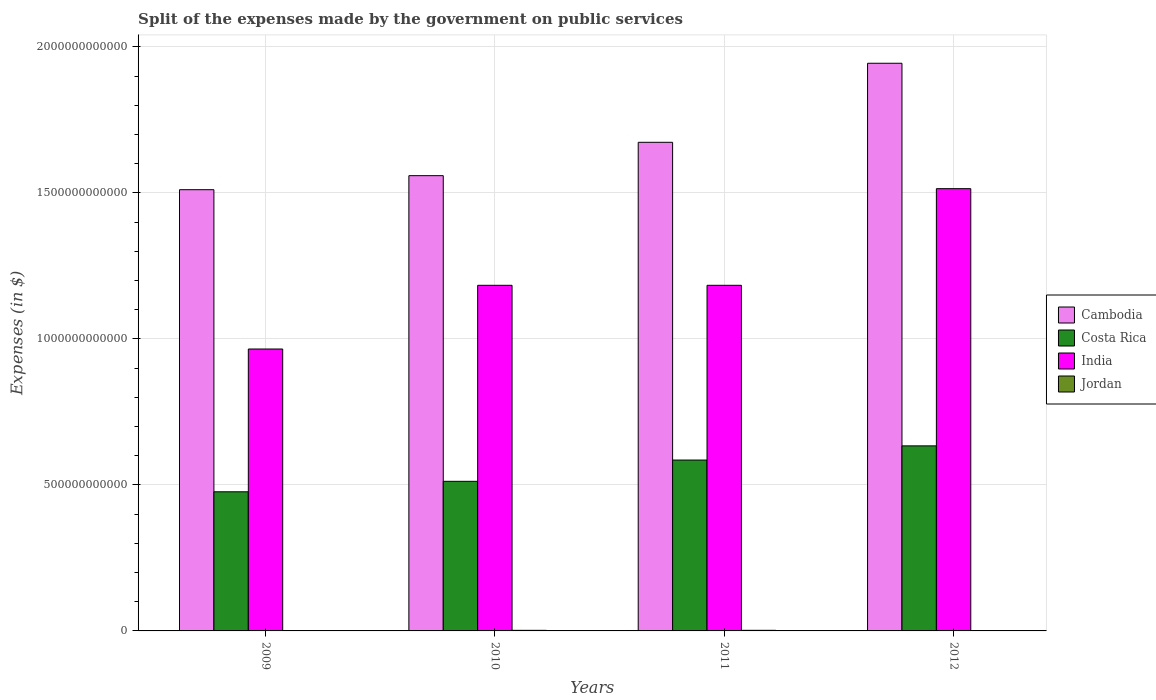Are the number of bars per tick equal to the number of legend labels?
Make the answer very short. Yes. How many bars are there on the 2nd tick from the left?
Offer a very short reply. 4. What is the label of the 4th group of bars from the left?
Your answer should be compact. 2012. What is the expenses made by the government on public services in India in 2011?
Keep it short and to the point. 1.18e+12. Across all years, what is the maximum expenses made by the government on public services in Cambodia?
Make the answer very short. 1.94e+12. Across all years, what is the minimum expenses made by the government on public services in Cambodia?
Make the answer very short. 1.51e+12. In which year was the expenses made by the government on public services in Jordan minimum?
Make the answer very short. 2012. What is the total expenses made by the government on public services in Jordan in the graph?
Offer a very short reply. 4.99e+09. What is the difference between the expenses made by the government on public services in India in 2010 and that in 2012?
Make the answer very short. -3.31e+11. What is the difference between the expenses made by the government on public services in Jordan in 2010 and the expenses made by the government on public services in Cambodia in 2012?
Offer a terse response. -1.94e+12. What is the average expenses made by the government on public services in India per year?
Your answer should be compact. 1.21e+12. In the year 2009, what is the difference between the expenses made by the government on public services in Cambodia and expenses made by the government on public services in Costa Rica?
Give a very brief answer. 1.03e+12. What is the ratio of the expenses made by the government on public services in Cambodia in 2009 to that in 2010?
Your response must be concise. 0.97. Is the difference between the expenses made by the government on public services in Cambodia in 2009 and 2010 greater than the difference between the expenses made by the government on public services in Costa Rica in 2009 and 2010?
Give a very brief answer. No. What is the difference between the highest and the second highest expenses made by the government on public services in Cambodia?
Give a very brief answer. 2.71e+11. What is the difference between the highest and the lowest expenses made by the government on public services in Costa Rica?
Keep it short and to the point. 1.57e+11. What does the 4th bar from the left in 2009 represents?
Offer a very short reply. Jordan. What does the 4th bar from the right in 2011 represents?
Offer a terse response. Cambodia. Are all the bars in the graph horizontal?
Offer a terse response. No. How many years are there in the graph?
Give a very brief answer. 4. What is the difference between two consecutive major ticks on the Y-axis?
Your answer should be compact. 5.00e+11. What is the title of the graph?
Your answer should be compact. Split of the expenses made by the government on public services. What is the label or title of the Y-axis?
Your answer should be very brief. Expenses (in $). What is the Expenses (in $) of Cambodia in 2009?
Offer a very short reply. 1.51e+12. What is the Expenses (in $) in Costa Rica in 2009?
Provide a succinct answer. 4.76e+11. What is the Expenses (in $) in India in 2009?
Your answer should be compact. 9.65e+11. What is the Expenses (in $) in Jordan in 2009?
Your answer should be compact. 5.69e+08. What is the Expenses (in $) in Cambodia in 2010?
Provide a short and direct response. 1.56e+12. What is the Expenses (in $) of Costa Rica in 2010?
Ensure brevity in your answer.  5.12e+11. What is the Expenses (in $) of India in 2010?
Ensure brevity in your answer.  1.18e+12. What is the Expenses (in $) of Jordan in 2010?
Provide a succinct answer. 2.01e+09. What is the Expenses (in $) in Cambodia in 2011?
Keep it short and to the point. 1.67e+12. What is the Expenses (in $) in Costa Rica in 2011?
Offer a very short reply. 5.85e+11. What is the Expenses (in $) of India in 2011?
Offer a very short reply. 1.18e+12. What is the Expenses (in $) in Jordan in 2011?
Your response must be concise. 2.06e+09. What is the Expenses (in $) of Cambodia in 2012?
Provide a short and direct response. 1.94e+12. What is the Expenses (in $) of Costa Rica in 2012?
Provide a succinct answer. 6.34e+11. What is the Expenses (in $) in India in 2012?
Your response must be concise. 1.51e+12. What is the Expenses (in $) in Jordan in 2012?
Give a very brief answer. 3.50e+08. Across all years, what is the maximum Expenses (in $) of Cambodia?
Your response must be concise. 1.94e+12. Across all years, what is the maximum Expenses (in $) in Costa Rica?
Keep it short and to the point. 6.34e+11. Across all years, what is the maximum Expenses (in $) of India?
Provide a short and direct response. 1.51e+12. Across all years, what is the maximum Expenses (in $) in Jordan?
Your answer should be compact. 2.06e+09. Across all years, what is the minimum Expenses (in $) in Cambodia?
Your response must be concise. 1.51e+12. Across all years, what is the minimum Expenses (in $) in Costa Rica?
Your answer should be very brief. 4.76e+11. Across all years, what is the minimum Expenses (in $) in India?
Keep it short and to the point. 9.65e+11. Across all years, what is the minimum Expenses (in $) in Jordan?
Keep it short and to the point. 3.50e+08. What is the total Expenses (in $) in Cambodia in the graph?
Provide a short and direct response. 6.69e+12. What is the total Expenses (in $) in Costa Rica in the graph?
Your response must be concise. 2.21e+12. What is the total Expenses (in $) in India in the graph?
Make the answer very short. 4.85e+12. What is the total Expenses (in $) in Jordan in the graph?
Offer a very short reply. 4.99e+09. What is the difference between the Expenses (in $) of Cambodia in 2009 and that in 2010?
Provide a short and direct response. -4.80e+1. What is the difference between the Expenses (in $) of Costa Rica in 2009 and that in 2010?
Offer a very short reply. -3.59e+1. What is the difference between the Expenses (in $) of India in 2009 and that in 2010?
Your answer should be very brief. -2.18e+11. What is the difference between the Expenses (in $) in Jordan in 2009 and that in 2010?
Give a very brief answer. -1.44e+09. What is the difference between the Expenses (in $) in Cambodia in 2009 and that in 2011?
Your response must be concise. -1.62e+11. What is the difference between the Expenses (in $) in Costa Rica in 2009 and that in 2011?
Ensure brevity in your answer.  -1.09e+11. What is the difference between the Expenses (in $) of India in 2009 and that in 2011?
Keep it short and to the point. -2.18e+11. What is the difference between the Expenses (in $) in Jordan in 2009 and that in 2011?
Offer a very short reply. -1.49e+09. What is the difference between the Expenses (in $) in Cambodia in 2009 and that in 2012?
Your answer should be very brief. -4.33e+11. What is the difference between the Expenses (in $) of Costa Rica in 2009 and that in 2012?
Offer a very short reply. -1.57e+11. What is the difference between the Expenses (in $) in India in 2009 and that in 2012?
Offer a very short reply. -5.49e+11. What is the difference between the Expenses (in $) of Jordan in 2009 and that in 2012?
Give a very brief answer. 2.19e+08. What is the difference between the Expenses (in $) of Cambodia in 2010 and that in 2011?
Offer a very short reply. -1.14e+11. What is the difference between the Expenses (in $) of Costa Rica in 2010 and that in 2011?
Your response must be concise. -7.28e+1. What is the difference between the Expenses (in $) of India in 2010 and that in 2011?
Your answer should be compact. 0. What is the difference between the Expenses (in $) in Jordan in 2010 and that in 2011?
Give a very brief answer. -5.55e+07. What is the difference between the Expenses (in $) of Cambodia in 2010 and that in 2012?
Keep it short and to the point. -3.85e+11. What is the difference between the Expenses (in $) in Costa Rica in 2010 and that in 2012?
Ensure brevity in your answer.  -1.21e+11. What is the difference between the Expenses (in $) of India in 2010 and that in 2012?
Give a very brief answer. -3.31e+11. What is the difference between the Expenses (in $) of Jordan in 2010 and that in 2012?
Offer a very short reply. 1.66e+09. What is the difference between the Expenses (in $) in Cambodia in 2011 and that in 2012?
Ensure brevity in your answer.  -2.71e+11. What is the difference between the Expenses (in $) of Costa Rica in 2011 and that in 2012?
Offer a terse response. -4.86e+1. What is the difference between the Expenses (in $) in India in 2011 and that in 2012?
Your answer should be very brief. -3.31e+11. What is the difference between the Expenses (in $) in Jordan in 2011 and that in 2012?
Keep it short and to the point. 1.71e+09. What is the difference between the Expenses (in $) of Cambodia in 2009 and the Expenses (in $) of Costa Rica in 2010?
Offer a terse response. 9.99e+11. What is the difference between the Expenses (in $) in Cambodia in 2009 and the Expenses (in $) in India in 2010?
Your response must be concise. 3.27e+11. What is the difference between the Expenses (in $) of Cambodia in 2009 and the Expenses (in $) of Jordan in 2010?
Provide a short and direct response. 1.51e+12. What is the difference between the Expenses (in $) of Costa Rica in 2009 and the Expenses (in $) of India in 2010?
Give a very brief answer. -7.07e+11. What is the difference between the Expenses (in $) in Costa Rica in 2009 and the Expenses (in $) in Jordan in 2010?
Make the answer very short. 4.74e+11. What is the difference between the Expenses (in $) in India in 2009 and the Expenses (in $) in Jordan in 2010?
Provide a succinct answer. 9.63e+11. What is the difference between the Expenses (in $) of Cambodia in 2009 and the Expenses (in $) of Costa Rica in 2011?
Give a very brief answer. 9.26e+11. What is the difference between the Expenses (in $) in Cambodia in 2009 and the Expenses (in $) in India in 2011?
Provide a short and direct response. 3.27e+11. What is the difference between the Expenses (in $) in Cambodia in 2009 and the Expenses (in $) in Jordan in 2011?
Keep it short and to the point. 1.51e+12. What is the difference between the Expenses (in $) of Costa Rica in 2009 and the Expenses (in $) of India in 2011?
Your response must be concise. -7.07e+11. What is the difference between the Expenses (in $) of Costa Rica in 2009 and the Expenses (in $) of Jordan in 2011?
Your response must be concise. 4.74e+11. What is the difference between the Expenses (in $) of India in 2009 and the Expenses (in $) of Jordan in 2011?
Your answer should be compact. 9.63e+11. What is the difference between the Expenses (in $) in Cambodia in 2009 and the Expenses (in $) in Costa Rica in 2012?
Provide a short and direct response. 8.77e+11. What is the difference between the Expenses (in $) in Cambodia in 2009 and the Expenses (in $) in India in 2012?
Provide a succinct answer. -3.51e+09. What is the difference between the Expenses (in $) of Cambodia in 2009 and the Expenses (in $) of Jordan in 2012?
Offer a very short reply. 1.51e+12. What is the difference between the Expenses (in $) of Costa Rica in 2009 and the Expenses (in $) of India in 2012?
Offer a very short reply. -1.04e+12. What is the difference between the Expenses (in $) of Costa Rica in 2009 and the Expenses (in $) of Jordan in 2012?
Keep it short and to the point. 4.76e+11. What is the difference between the Expenses (in $) in India in 2009 and the Expenses (in $) in Jordan in 2012?
Your response must be concise. 9.65e+11. What is the difference between the Expenses (in $) in Cambodia in 2010 and the Expenses (in $) in Costa Rica in 2011?
Ensure brevity in your answer.  9.74e+11. What is the difference between the Expenses (in $) of Cambodia in 2010 and the Expenses (in $) of India in 2011?
Your answer should be very brief. 3.75e+11. What is the difference between the Expenses (in $) in Cambodia in 2010 and the Expenses (in $) in Jordan in 2011?
Your answer should be very brief. 1.56e+12. What is the difference between the Expenses (in $) in Costa Rica in 2010 and the Expenses (in $) in India in 2011?
Provide a succinct answer. -6.71e+11. What is the difference between the Expenses (in $) of Costa Rica in 2010 and the Expenses (in $) of Jordan in 2011?
Offer a very short reply. 5.10e+11. What is the difference between the Expenses (in $) of India in 2010 and the Expenses (in $) of Jordan in 2011?
Provide a short and direct response. 1.18e+12. What is the difference between the Expenses (in $) in Cambodia in 2010 and the Expenses (in $) in Costa Rica in 2012?
Your response must be concise. 9.25e+11. What is the difference between the Expenses (in $) in Cambodia in 2010 and the Expenses (in $) in India in 2012?
Provide a succinct answer. 4.45e+1. What is the difference between the Expenses (in $) of Cambodia in 2010 and the Expenses (in $) of Jordan in 2012?
Provide a short and direct response. 1.56e+12. What is the difference between the Expenses (in $) of Costa Rica in 2010 and the Expenses (in $) of India in 2012?
Keep it short and to the point. -1.00e+12. What is the difference between the Expenses (in $) in Costa Rica in 2010 and the Expenses (in $) in Jordan in 2012?
Your response must be concise. 5.12e+11. What is the difference between the Expenses (in $) of India in 2010 and the Expenses (in $) of Jordan in 2012?
Give a very brief answer. 1.18e+12. What is the difference between the Expenses (in $) in Cambodia in 2011 and the Expenses (in $) in Costa Rica in 2012?
Make the answer very short. 1.04e+12. What is the difference between the Expenses (in $) in Cambodia in 2011 and the Expenses (in $) in India in 2012?
Offer a very short reply. 1.59e+11. What is the difference between the Expenses (in $) in Cambodia in 2011 and the Expenses (in $) in Jordan in 2012?
Your answer should be compact. 1.67e+12. What is the difference between the Expenses (in $) of Costa Rica in 2011 and the Expenses (in $) of India in 2012?
Offer a terse response. -9.29e+11. What is the difference between the Expenses (in $) in Costa Rica in 2011 and the Expenses (in $) in Jordan in 2012?
Provide a short and direct response. 5.85e+11. What is the difference between the Expenses (in $) in India in 2011 and the Expenses (in $) in Jordan in 2012?
Offer a very short reply. 1.18e+12. What is the average Expenses (in $) in Cambodia per year?
Your answer should be very brief. 1.67e+12. What is the average Expenses (in $) of Costa Rica per year?
Offer a very short reply. 5.52e+11. What is the average Expenses (in $) of India per year?
Provide a succinct answer. 1.21e+12. What is the average Expenses (in $) in Jordan per year?
Your answer should be compact. 1.25e+09. In the year 2009, what is the difference between the Expenses (in $) of Cambodia and Expenses (in $) of Costa Rica?
Give a very brief answer. 1.03e+12. In the year 2009, what is the difference between the Expenses (in $) of Cambodia and Expenses (in $) of India?
Keep it short and to the point. 5.46e+11. In the year 2009, what is the difference between the Expenses (in $) of Cambodia and Expenses (in $) of Jordan?
Keep it short and to the point. 1.51e+12. In the year 2009, what is the difference between the Expenses (in $) of Costa Rica and Expenses (in $) of India?
Give a very brief answer. -4.89e+11. In the year 2009, what is the difference between the Expenses (in $) in Costa Rica and Expenses (in $) in Jordan?
Your answer should be compact. 4.76e+11. In the year 2009, what is the difference between the Expenses (in $) of India and Expenses (in $) of Jordan?
Your response must be concise. 9.65e+11. In the year 2010, what is the difference between the Expenses (in $) of Cambodia and Expenses (in $) of Costa Rica?
Ensure brevity in your answer.  1.05e+12. In the year 2010, what is the difference between the Expenses (in $) of Cambodia and Expenses (in $) of India?
Offer a very short reply. 3.75e+11. In the year 2010, what is the difference between the Expenses (in $) of Cambodia and Expenses (in $) of Jordan?
Provide a succinct answer. 1.56e+12. In the year 2010, what is the difference between the Expenses (in $) in Costa Rica and Expenses (in $) in India?
Give a very brief answer. -6.71e+11. In the year 2010, what is the difference between the Expenses (in $) in Costa Rica and Expenses (in $) in Jordan?
Your answer should be very brief. 5.10e+11. In the year 2010, what is the difference between the Expenses (in $) of India and Expenses (in $) of Jordan?
Your answer should be very brief. 1.18e+12. In the year 2011, what is the difference between the Expenses (in $) in Cambodia and Expenses (in $) in Costa Rica?
Keep it short and to the point. 1.09e+12. In the year 2011, what is the difference between the Expenses (in $) of Cambodia and Expenses (in $) of India?
Your answer should be very brief. 4.90e+11. In the year 2011, what is the difference between the Expenses (in $) of Cambodia and Expenses (in $) of Jordan?
Offer a very short reply. 1.67e+12. In the year 2011, what is the difference between the Expenses (in $) of Costa Rica and Expenses (in $) of India?
Ensure brevity in your answer.  -5.98e+11. In the year 2011, what is the difference between the Expenses (in $) in Costa Rica and Expenses (in $) in Jordan?
Your response must be concise. 5.83e+11. In the year 2011, what is the difference between the Expenses (in $) in India and Expenses (in $) in Jordan?
Your answer should be compact. 1.18e+12. In the year 2012, what is the difference between the Expenses (in $) of Cambodia and Expenses (in $) of Costa Rica?
Offer a very short reply. 1.31e+12. In the year 2012, what is the difference between the Expenses (in $) of Cambodia and Expenses (in $) of India?
Offer a very short reply. 4.29e+11. In the year 2012, what is the difference between the Expenses (in $) of Cambodia and Expenses (in $) of Jordan?
Your response must be concise. 1.94e+12. In the year 2012, what is the difference between the Expenses (in $) of Costa Rica and Expenses (in $) of India?
Provide a succinct answer. -8.81e+11. In the year 2012, what is the difference between the Expenses (in $) in Costa Rica and Expenses (in $) in Jordan?
Offer a very short reply. 6.33e+11. In the year 2012, what is the difference between the Expenses (in $) of India and Expenses (in $) of Jordan?
Provide a short and direct response. 1.51e+12. What is the ratio of the Expenses (in $) in Cambodia in 2009 to that in 2010?
Your answer should be very brief. 0.97. What is the ratio of the Expenses (in $) of India in 2009 to that in 2010?
Keep it short and to the point. 0.82. What is the ratio of the Expenses (in $) in Jordan in 2009 to that in 2010?
Keep it short and to the point. 0.28. What is the ratio of the Expenses (in $) in Cambodia in 2009 to that in 2011?
Your answer should be very brief. 0.9. What is the ratio of the Expenses (in $) in Costa Rica in 2009 to that in 2011?
Make the answer very short. 0.81. What is the ratio of the Expenses (in $) of India in 2009 to that in 2011?
Your answer should be very brief. 0.82. What is the ratio of the Expenses (in $) of Jordan in 2009 to that in 2011?
Your response must be concise. 0.28. What is the ratio of the Expenses (in $) of Cambodia in 2009 to that in 2012?
Offer a terse response. 0.78. What is the ratio of the Expenses (in $) of Costa Rica in 2009 to that in 2012?
Offer a very short reply. 0.75. What is the ratio of the Expenses (in $) of India in 2009 to that in 2012?
Give a very brief answer. 0.64. What is the ratio of the Expenses (in $) of Jordan in 2009 to that in 2012?
Offer a terse response. 1.63. What is the ratio of the Expenses (in $) of Cambodia in 2010 to that in 2011?
Provide a succinct answer. 0.93. What is the ratio of the Expenses (in $) in Costa Rica in 2010 to that in 2011?
Your answer should be compact. 0.88. What is the ratio of the Expenses (in $) of Jordan in 2010 to that in 2011?
Provide a succinct answer. 0.97. What is the ratio of the Expenses (in $) in Cambodia in 2010 to that in 2012?
Provide a short and direct response. 0.8. What is the ratio of the Expenses (in $) in Costa Rica in 2010 to that in 2012?
Your answer should be compact. 0.81. What is the ratio of the Expenses (in $) in India in 2010 to that in 2012?
Keep it short and to the point. 0.78. What is the ratio of the Expenses (in $) in Jordan in 2010 to that in 2012?
Make the answer very short. 5.73. What is the ratio of the Expenses (in $) in Cambodia in 2011 to that in 2012?
Provide a short and direct response. 0.86. What is the ratio of the Expenses (in $) of Costa Rica in 2011 to that in 2012?
Offer a very short reply. 0.92. What is the ratio of the Expenses (in $) in India in 2011 to that in 2012?
Give a very brief answer. 0.78. What is the ratio of the Expenses (in $) in Jordan in 2011 to that in 2012?
Make the answer very short. 5.89. What is the difference between the highest and the second highest Expenses (in $) of Cambodia?
Give a very brief answer. 2.71e+11. What is the difference between the highest and the second highest Expenses (in $) of Costa Rica?
Offer a very short reply. 4.86e+1. What is the difference between the highest and the second highest Expenses (in $) in India?
Provide a short and direct response. 3.31e+11. What is the difference between the highest and the second highest Expenses (in $) in Jordan?
Give a very brief answer. 5.55e+07. What is the difference between the highest and the lowest Expenses (in $) in Cambodia?
Provide a succinct answer. 4.33e+11. What is the difference between the highest and the lowest Expenses (in $) in Costa Rica?
Provide a succinct answer. 1.57e+11. What is the difference between the highest and the lowest Expenses (in $) in India?
Give a very brief answer. 5.49e+11. What is the difference between the highest and the lowest Expenses (in $) in Jordan?
Provide a short and direct response. 1.71e+09. 